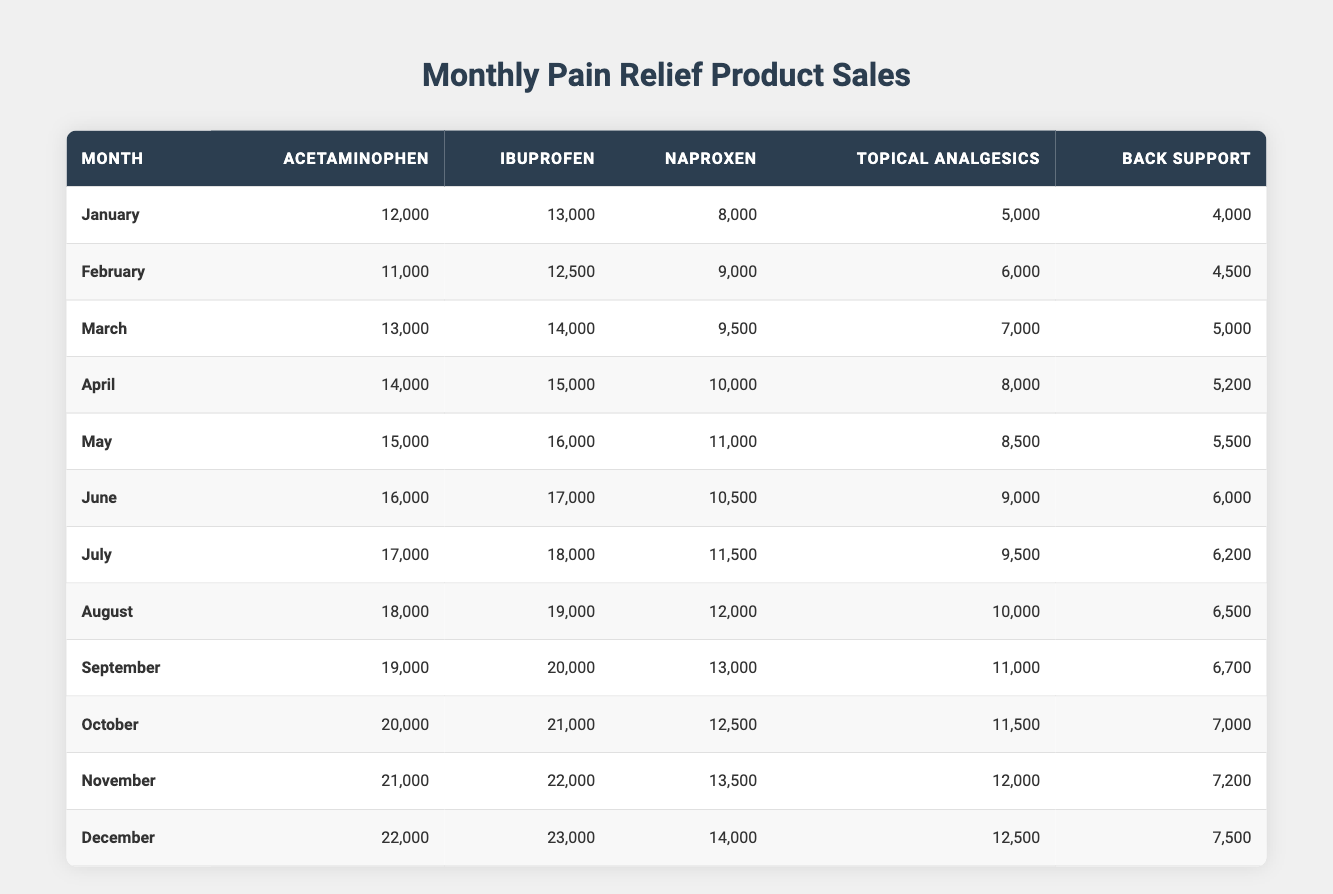What is the highest sales month for ibuprofen? Looking at the table, the highest sales figure for ibuprofen is found in December with 23,000 units sold.
Answer: 23,000 Which pain relief product had the lowest sales in January? In January, the sales for different products were: acetaminophen (12,000), ibuprofen (13,000), naproxen (8,000), topical analgesics (5,000), and back support (4,000). The lowest sales were for back support.
Answer: Back support What was the average sales for acetaminophen throughout the year? The acetaminophen sales figures for each month are: (12,000 + 11,000 + 13,000 + 14,000 + 15,000 + 16,000 + 17,000 + 18,000 + 19,000 + 20,000 + 21,000 + 22,000) =  219,000. There are 12 months, so the average is 219,000 / 12 = 18,250.
Answer: 18,250 Is it true that sales for topical analgesics increased every month? Checking the monthly sales for topical analgesics reveals: January (5,000), February (6,000), March (7,000), April (8,000), May (8,500), June (9,000), July (9,500), August (10,000), September (11,000), October (11,500), November (12,000), December (12,500). This shows a consistent increase each month.
Answer: Yes What is the difference in sales between the highest and lowest month for back support? The highest sales for back support is in December (7,500), and the lowest is in January (4,000). The difference is 7,500 - 4,000 = 3,500.
Answer: 3,500 Which month had the highest combined sales of acetaminophen and ibuprofen? Calculating the combined sales for each month: (January: 25,000), (February: 23,500), (March: 27,000), (April: 29,000), (May: 31,000), (June: 33,000), (July: 35,000), (August: 37,000), (September: 39,000), (October: 41,000), (November: 43,000), and (December: 45,000). The highest combined sales occurred in December with 45,000.
Answer: December What is the sales trend for naproxen throughout the year? The monthly sales figures for naproxen are: January (8,000), February (9,000), March (9,500), April (10,000), May (11,000), June (10,500), July (11,500), August (12,000), September (13,000), October (12,500), November (13,500), December (14,000). The overall trend shows an increase, but there are fluctuations in June and October where sales decreased compared to the previous months.
Answer: Generally increasing with fluctuations Was there a month where back support sales were below 5,000 units? The sales figures for back support show: January (4,000), February (4,500), March (5,000), April (5,200), May (5,500), June (6,000), July (6,200), August (6,500), September (6,700), October (7,000), November (7,200), and December (7,500). There were months (January and February) where sales were below 5,000.
Answer: Yes 